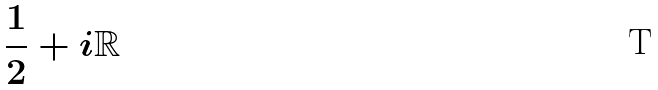Convert formula to latex. <formula><loc_0><loc_0><loc_500><loc_500>\frac { 1 } { 2 } + i \mathbb { R }</formula> 